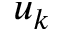<formula> <loc_0><loc_0><loc_500><loc_500>u _ { k }</formula> 